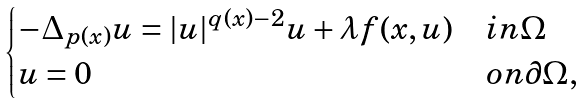Convert formula to latex. <formula><loc_0><loc_0><loc_500><loc_500>\begin{cases} - \Delta _ { p ( x ) } u = | u | ^ { q ( x ) - 2 } u + \lambda f ( x , u ) & i n \Omega \\ u = 0 & o n \partial \Omega , \end{cases}</formula> 